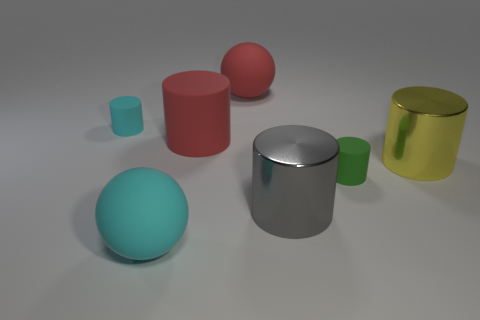Subtract all big gray cylinders. How many cylinders are left? 4 Subtract all cylinders. How many objects are left? 2 Add 3 cyan cylinders. How many objects exist? 10 Subtract all cyan cylinders. How many cylinders are left? 4 Subtract 1 red cylinders. How many objects are left? 6 Subtract 1 cylinders. How many cylinders are left? 4 Subtract all brown cylinders. Subtract all purple blocks. How many cylinders are left? 5 Subtract all red cylinders. How many brown balls are left? 0 Subtract all small matte cylinders. Subtract all green shiny blocks. How many objects are left? 5 Add 2 tiny green cylinders. How many tiny green cylinders are left? 3 